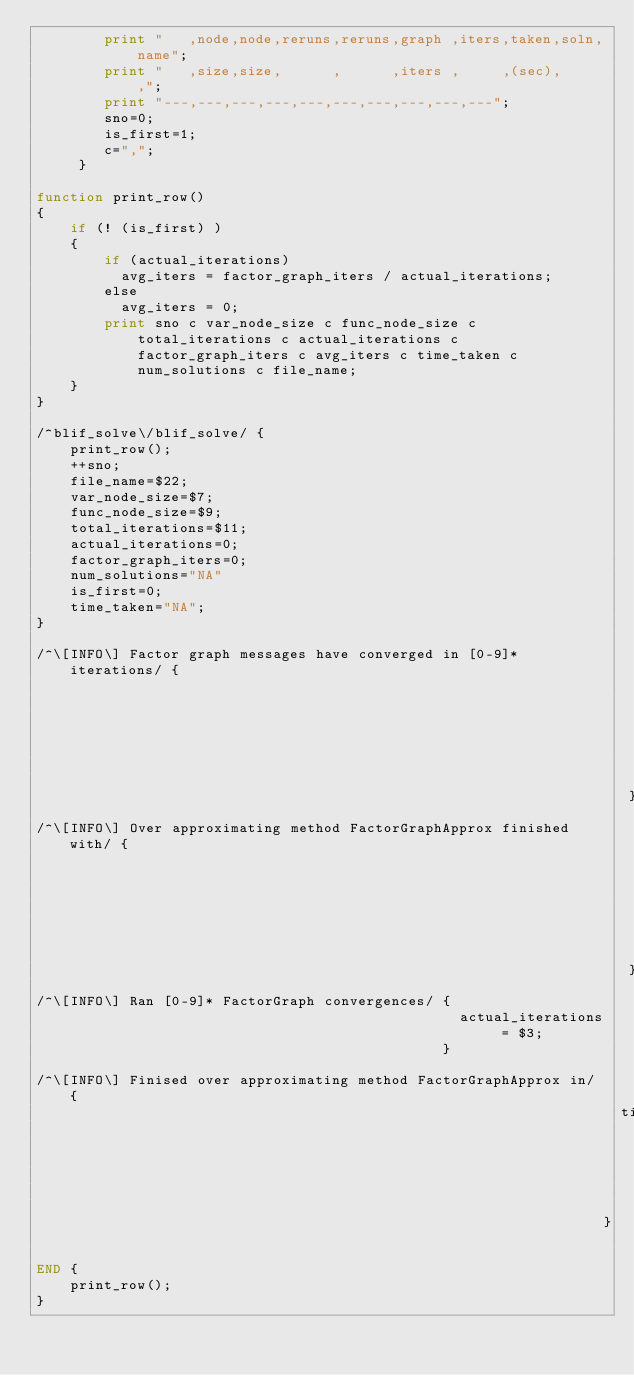Convert code to text. <code><loc_0><loc_0><loc_500><loc_500><_Awk_>        print "   ,node,node,reruns,reruns,graph ,iters,taken,soln,name";
        print "   ,size,size,      ,      ,iters ,     ,(sec),     ,";
        print "---,---,---,---,---,---,---,---,---,---";
        sno=0;
        is_first=1;
        c=",";
     }

function print_row()
{
    if (! (is_first) )
    {
        if (actual_iterations)
          avg_iters = factor_graph_iters / actual_iterations;
        else
          avg_iters = 0;
        print sno c var_node_size c func_node_size c total_iterations c actual_iterations c factor_graph_iters c avg_iters c time_taken c num_solutions c file_name;
    }
}

/^blif_solve\/blif_solve/ {
    print_row();
    ++sno; 
    file_name=$22; 
    var_node_size=$7; 
    func_node_size=$9;
    total_iterations=$11;
    actual_iterations=0;
    factor_graph_iters=0;
    num_solutions="NA"
    is_first=0;
    time_taken="NA";
}

/^\[INFO\] Factor graph messages have converged in [0-9]* iterations/ {
                                                                        factor_graph_iters += $8;
                                                                      }
/^\[INFO\] Over approximating method FactorGraphApprox finished with/ {
                                                                        num_solutions = $8;
                                                                      }
/^\[INFO\] Ran [0-9]* FactorGraph convergences/ {
                                                  actual_iterations = $3;
                                                }

/^\[INFO\] Finised over approximating method FactorGraphApprox in/ {
                                                                     time_taken = $8;
                                                                   }

END {
    print_row();
}
</code> 